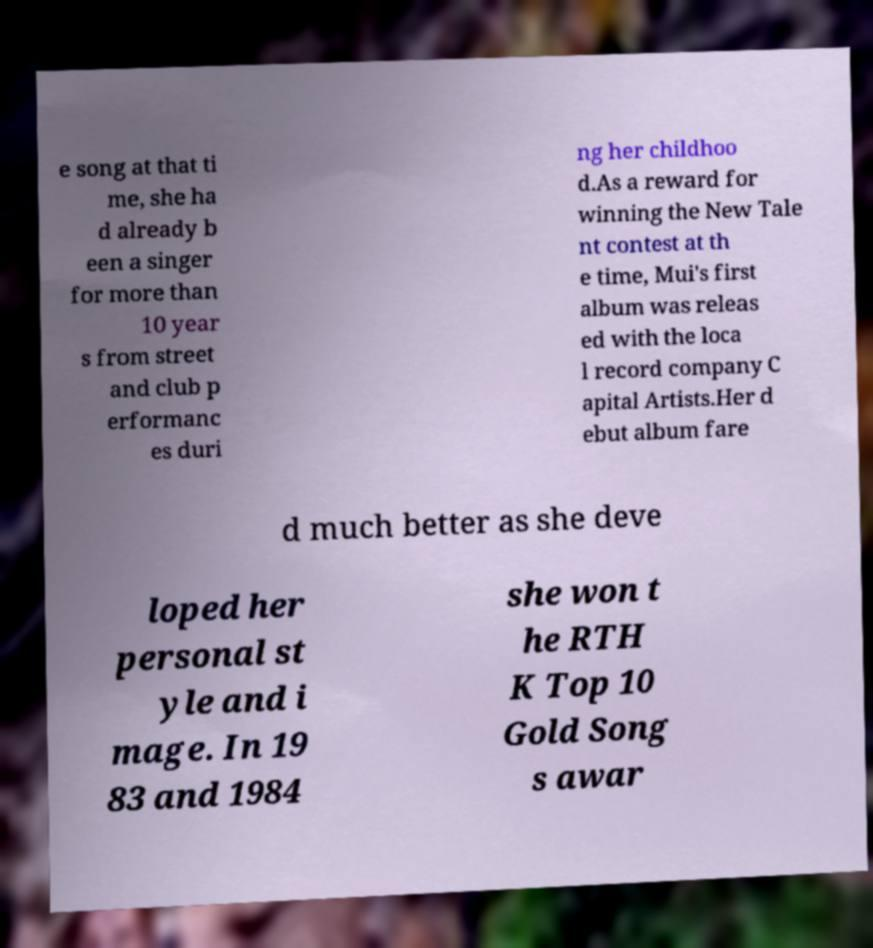I need the written content from this picture converted into text. Can you do that? e song at that ti me, she ha d already b een a singer for more than 10 year s from street and club p erformanc es duri ng her childhoo d.As a reward for winning the New Tale nt contest at th e time, Mui's first album was releas ed with the loca l record company C apital Artists.Her d ebut album fare d much better as she deve loped her personal st yle and i mage. In 19 83 and 1984 she won t he RTH K Top 10 Gold Song s awar 